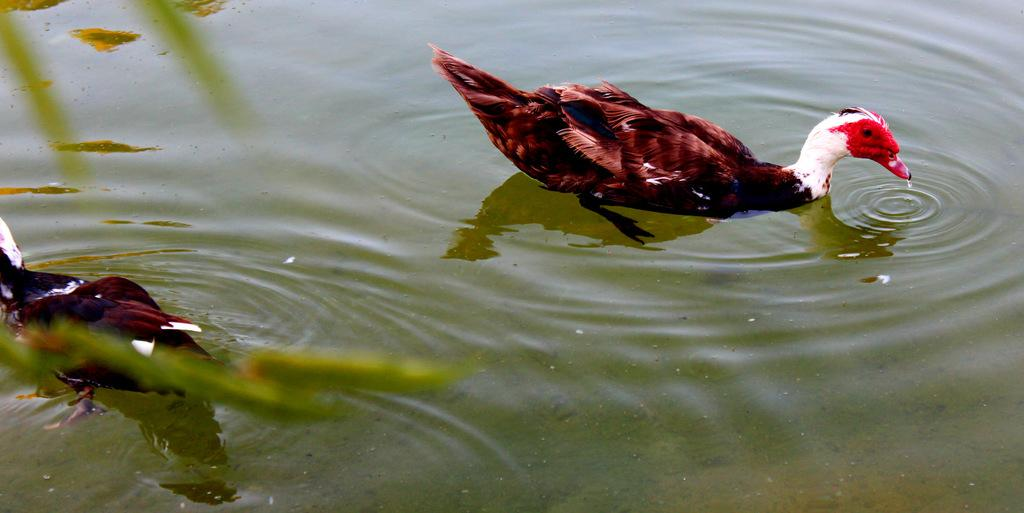What type of animal can be seen in the image? There is a bird in the image. Where is the bird located in the image? The bird is in the water. What color is the scarf that the bird is wearing in the image? There is no scarf present in the image, as birds do not wear clothing. 